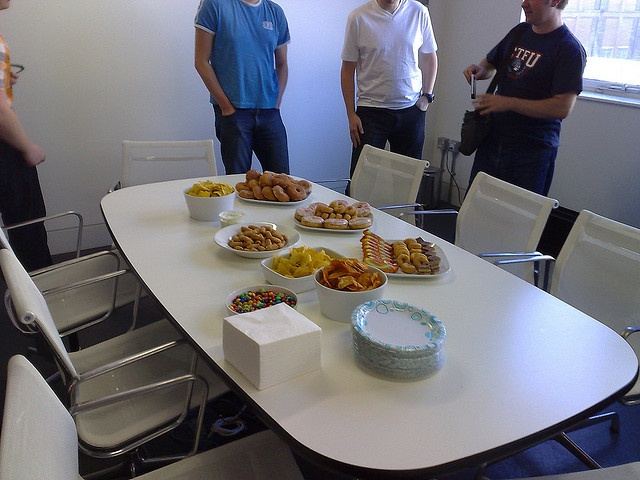Describe the objects in this image and their specific colors. I can see dining table in brown, darkgray, gray, and lavender tones, chair in brown, gray, black, and darkgray tones, people in brown, black, maroon, gray, and navy tones, people in brown, blue, black, navy, and gray tones, and people in brown, black, gray, and darkgray tones in this image. 